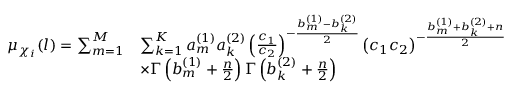Convert formula to latex. <formula><loc_0><loc_0><loc_500><loc_500>\begin{array} { r l } { \mu _ { \chi _ { i } } ( l ) = \sum _ { m = 1 } ^ { M } } & { \sum _ { k = 1 } ^ { K } a _ { m } ^ { ( 1 ) } a _ { k } ^ { ( 2 ) } \left ( \frac { c _ { 1 } } { c _ { 2 } } \right ) ^ { - \frac { b _ { m } ^ { ( 1 ) } - b _ { k } ^ { ( 2 ) } } { 2 } } \left ( c _ { 1 } c _ { 2 } \right ) ^ { - \frac { b _ { m } ^ { ( 1 ) } + b _ { k } ^ { ( 2 ) } + n } { 2 } } } \\ & { \times \Gamma \left ( b _ { m } ^ { ( 1 ) } + \frac { n } { 2 } \right ) \Gamma \left ( b _ { k } ^ { ( 2 ) } + \frac { n } { 2 } \right ) } \end{array}</formula> 